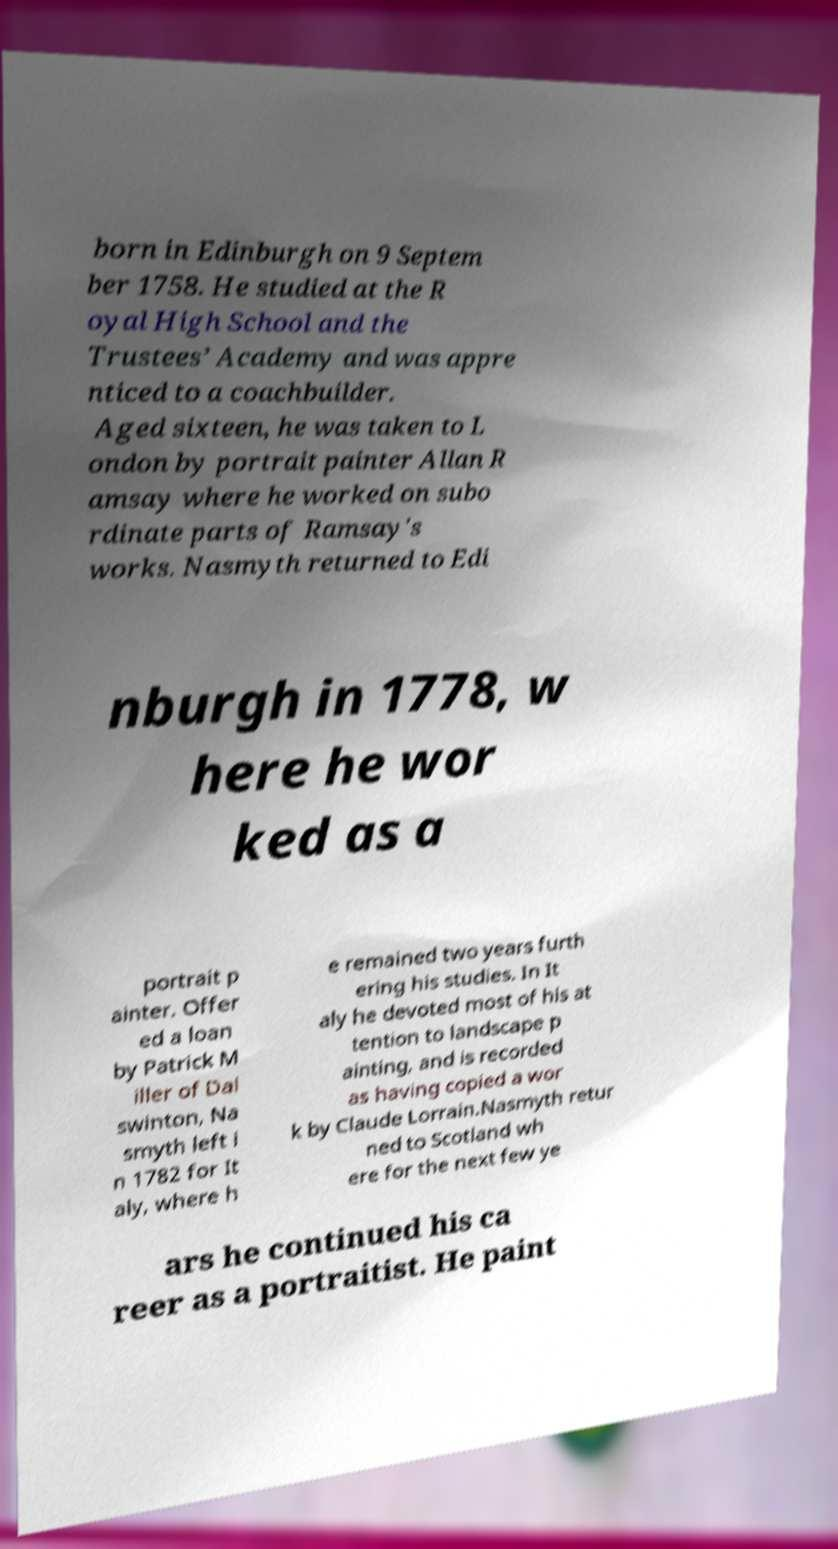Could you extract and type out the text from this image? born in Edinburgh on 9 Septem ber 1758. He studied at the R oyal High School and the Trustees’ Academy and was appre nticed to a coachbuilder. Aged sixteen, he was taken to L ondon by portrait painter Allan R amsay where he worked on subo rdinate parts of Ramsay's works. Nasmyth returned to Edi nburgh in 1778, w here he wor ked as a portrait p ainter. Offer ed a loan by Patrick M iller of Dal swinton, Na smyth left i n 1782 for It aly, where h e remained two years furth ering his studies. In It aly he devoted most of his at tention to landscape p ainting, and is recorded as having copied a wor k by Claude Lorrain.Nasmyth retur ned to Scotland wh ere for the next few ye ars he continued his ca reer as a portraitist. He paint 